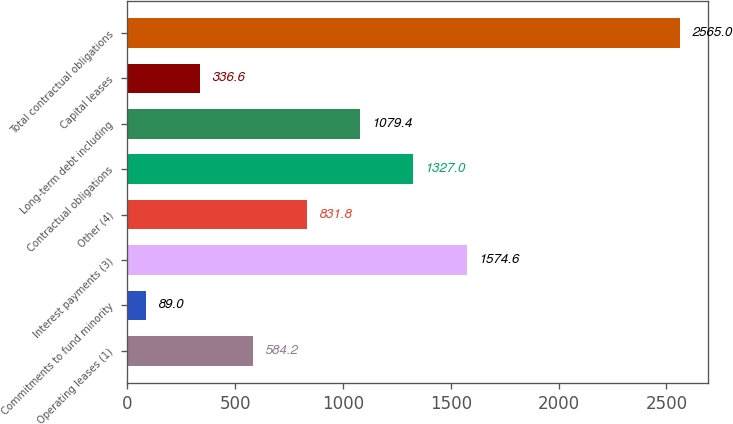<chart> <loc_0><loc_0><loc_500><loc_500><bar_chart><fcel>Operating leases (1)<fcel>Commitments to fund minority<fcel>Interest payments (3)<fcel>Other (4)<fcel>Contractual obligations<fcel>Long-term debt including<fcel>Capital leases<fcel>Total contractual obligations<nl><fcel>584.2<fcel>89<fcel>1574.6<fcel>831.8<fcel>1327<fcel>1079.4<fcel>336.6<fcel>2565<nl></chart> 